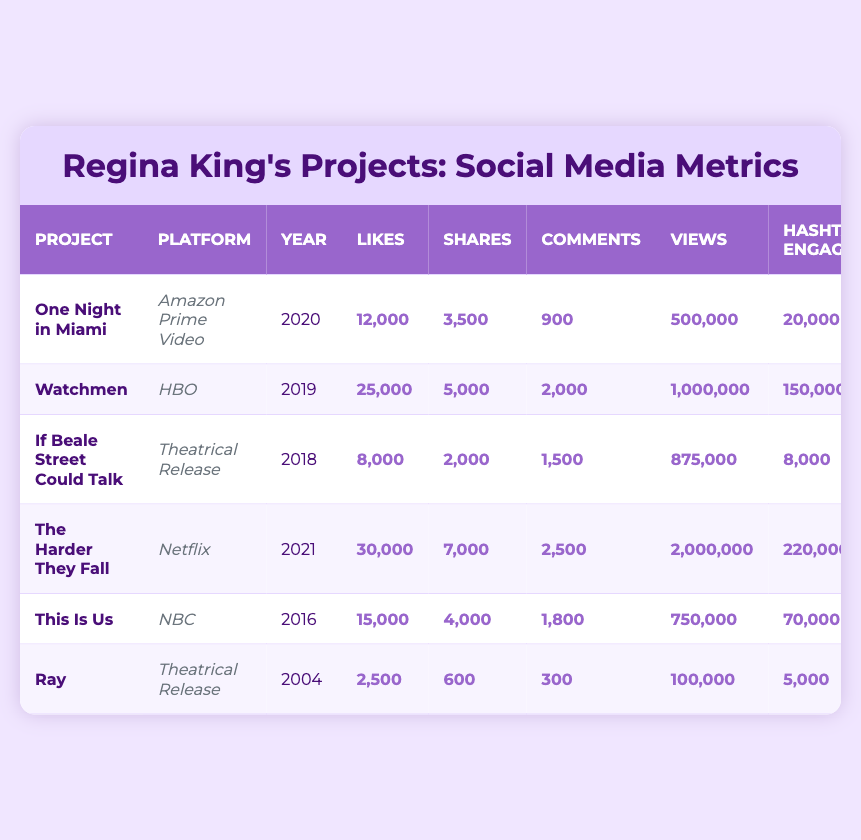What project had the highest number of views? The views for each project are listed in the table. "The Harder They Fall" has 2,000,000 views, which is higher than any other project.
Answer: The Harder They Fall Which project had the least hashtag engagement? The hashtag engagement numbers are shown for each project. "Ray" has 5,000 as its hashtag engagement, which is the lowest compared to other projects.
Answer: Ray What is the total number of likes across all projects? To find the total likes, add the likes from all projects: 12,000 + 25,000 + 8,000 + 30,000 + 15,000 + 2,500 = 92,500.
Answer: 92,500 Did "If Beale Street Could Talk" have more shares than "One Night in Miami"? "If Beale Street Could Talk" had 2,000 shares and "One Night in Miami" had 3,500 shares. Since 2,000 is less than 3,500, the statement is false.
Answer: No What is the average number of comments for all projects? To calculate the average, first sum the comments: 900 + 2000 + 1500 + 2500 + 1800 + 300 = 8,000. There are 6 projects, so the average is 8,000 divided by 6, which equals approximately 1,333.33.
Answer: 1,333.33 Which platform had the most likes for its project? The likes for each project are listed along with their platforms. "The Harder They Fall" on Netflix has 30,000 likes, which is more than any other project.
Answer: Netflix Is the number of views for "Watchmen" greater than that for "This Is Us"? "Watchmen" has 1,000,000 views, while "This Is Us" has 750,000 views. Since 1,000,000 is greater than 750,000, the statement is true.
Answer: Yes What is the difference in hashtag engagement between "The Harder They Fall" and "If Beale Street Could Talk"? "The Harder They Fall" has 220,000 hashtag engagements and "If Beale Street Could Talk" has 8,000. The difference is 220,000 - 8,000 = 212,000.
Answer: 212,000 How many projects were released after 2018? The projects released after 2018 are "One Night in Miami" (2020), "The Harder They Fall" (2021). There are 2 such projects.
Answer: 2 Which project had the highest number of comments? The number of comments for each project shows that "The Harder They Fall" had 2,500 comments, more than any other project.
Answer: The Harder They Fall 